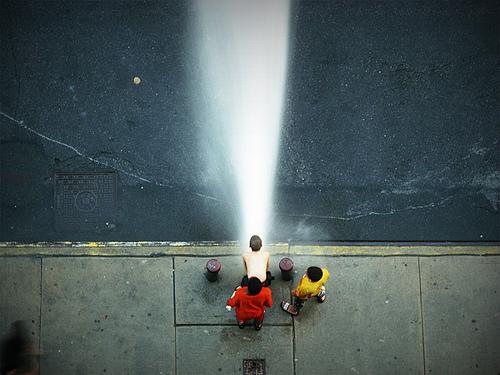Is the curb an emergency only area?
Write a very short answer. No. What are these children doing?
Keep it brief. Playing in water. How many children are there?
Keep it brief. 3. 